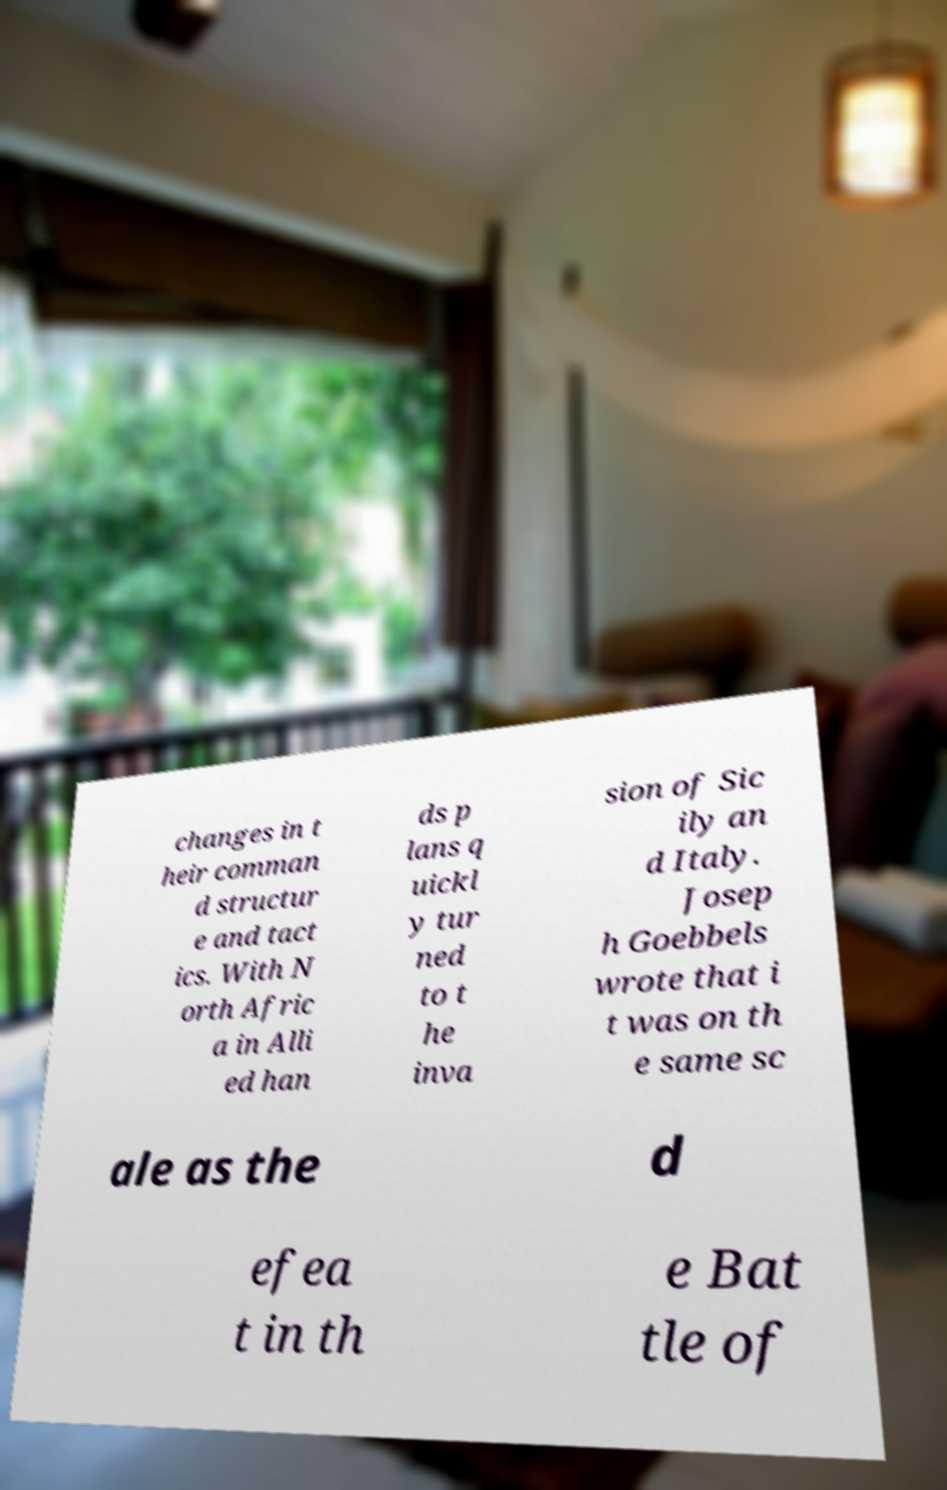Please read and relay the text visible in this image. What does it say? changes in t heir comman d structur e and tact ics. With N orth Afric a in Alli ed han ds p lans q uickl y tur ned to t he inva sion of Sic ily an d Italy. Josep h Goebbels wrote that i t was on th e same sc ale as the d efea t in th e Bat tle of 